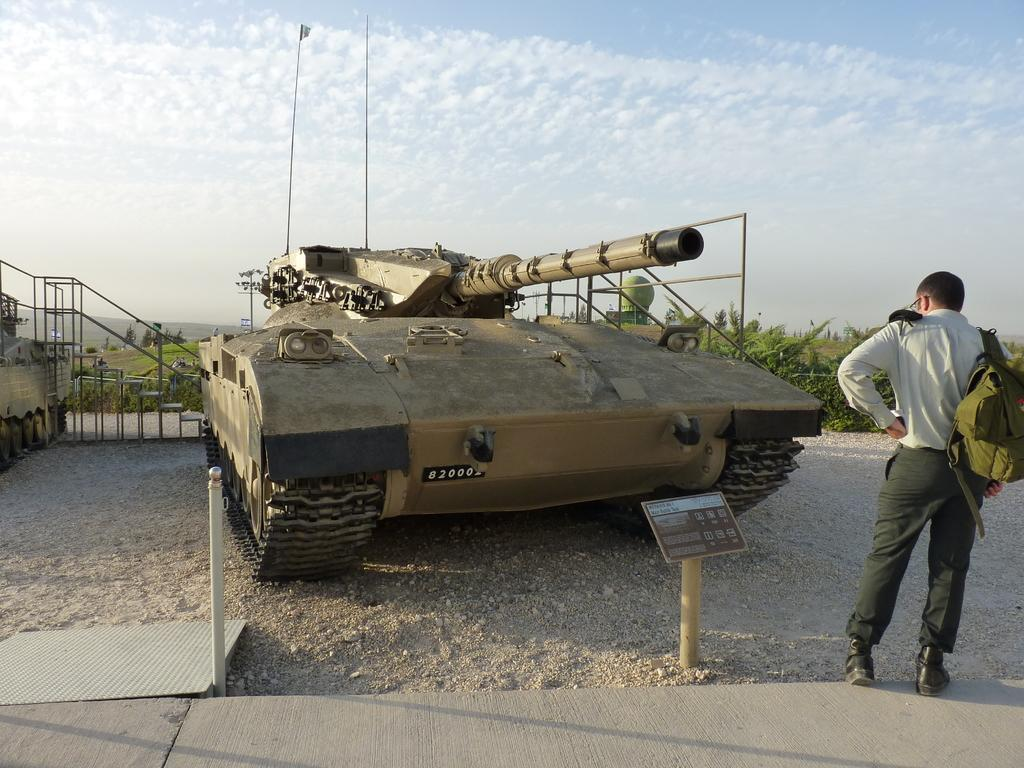What is the main subject of the image? There is a person standing in the image. What is the person wearing in the image? The person is wearing a bag. What other object can be seen in the image? There is a tank in the image. What can be seen in the background of the image? Trees and the sky are visible in the background of the image. Can you see any wrens flying around the tank in the image? There are no wrens visible in the image. What type of alarm is going off near the person in the image? There is no alarm present in the image. 